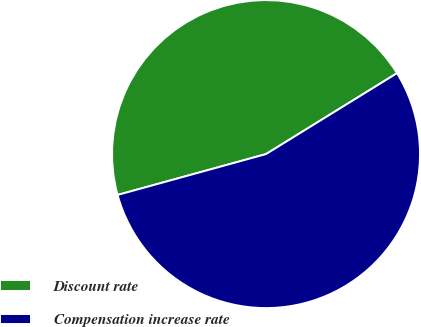<chart> <loc_0><loc_0><loc_500><loc_500><pie_chart><fcel>Discount rate<fcel>Compensation increase rate<nl><fcel>45.47%<fcel>54.53%<nl></chart> 